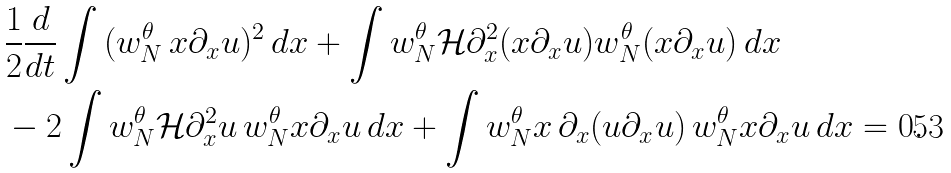Convert formula to latex. <formula><loc_0><loc_0><loc_500><loc_500>& \frac { 1 } { 2 } \frac { d } { d t } \int { ( w _ { N } ^ { \theta } \, x \partial _ { x } u ) ^ { 2 } \, d x } + \int { w _ { N } ^ { \theta } \mathcal { H } \partial _ { x } ^ { 2 } ( x \partial _ { x } u ) w _ { N } ^ { \theta } ( x \partial _ { x } u ) \, d x } \\ & - 2 \int w _ { N } ^ { \theta } \mathcal { H } \partial _ { x } ^ { 2 } u \, w _ { N } ^ { \theta } x \partial _ { x } u \, d x + \int { w _ { N } ^ { \theta } x \, \partial _ { x } ( u \partial _ { x } u ) \, w _ { N } ^ { \theta } x \partial _ { x } u \, d x } = 0 .</formula> 